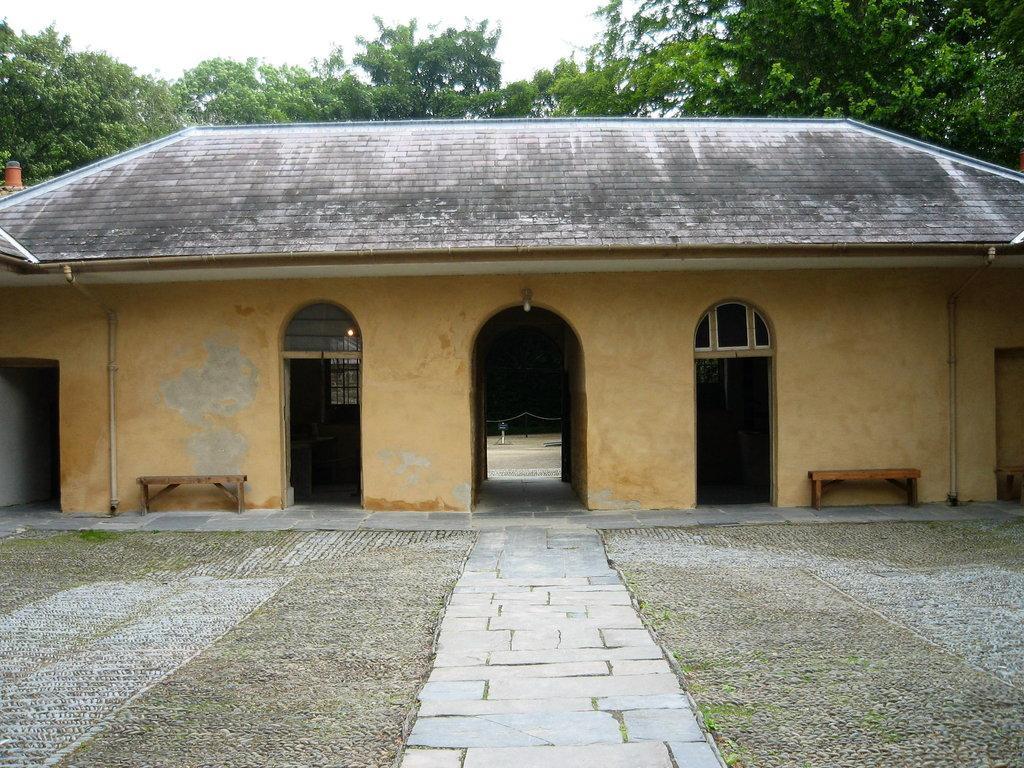Describe this image in one or two sentences. In this image we can see the house, benches and also the path. In the background we can see the trees and also the sky. 